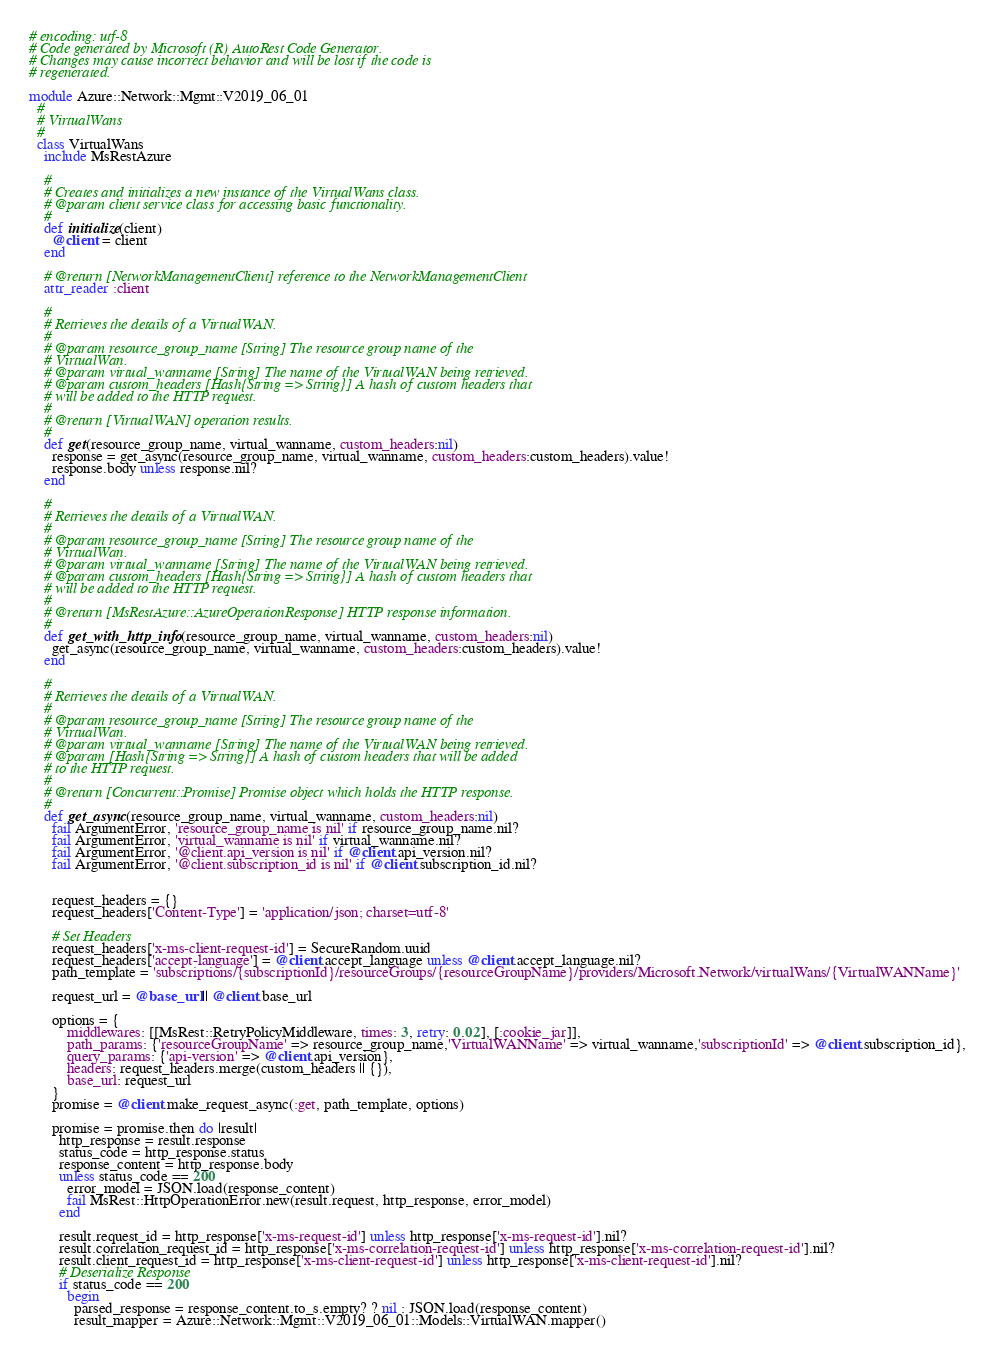Convert code to text. <code><loc_0><loc_0><loc_500><loc_500><_Ruby_># encoding: utf-8
# Code generated by Microsoft (R) AutoRest Code Generator.
# Changes may cause incorrect behavior and will be lost if the code is
# regenerated.

module Azure::Network::Mgmt::V2019_06_01
  #
  # VirtualWans
  #
  class VirtualWans
    include MsRestAzure

    #
    # Creates and initializes a new instance of the VirtualWans class.
    # @param client service class for accessing basic functionality.
    #
    def initialize(client)
      @client = client
    end

    # @return [NetworkManagementClient] reference to the NetworkManagementClient
    attr_reader :client

    #
    # Retrieves the details of a VirtualWAN.
    #
    # @param resource_group_name [String] The resource group name of the
    # VirtualWan.
    # @param virtual_wanname [String] The name of the VirtualWAN being retrieved.
    # @param custom_headers [Hash{String => String}] A hash of custom headers that
    # will be added to the HTTP request.
    #
    # @return [VirtualWAN] operation results.
    #
    def get(resource_group_name, virtual_wanname, custom_headers:nil)
      response = get_async(resource_group_name, virtual_wanname, custom_headers:custom_headers).value!
      response.body unless response.nil?
    end

    #
    # Retrieves the details of a VirtualWAN.
    #
    # @param resource_group_name [String] The resource group name of the
    # VirtualWan.
    # @param virtual_wanname [String] The name of the VirtualWAN being retrieved.
    # @param custom_headers [Hash{String => String}] A hash of custom headers that
    # will be added to the HTTP request.
    #
    # @return [MsRestAzure::AzureOperationResponse] HTTP response information.
    #
    def get_with_http_info(resource_group_name, virtual_wanname, custom_headers:nil)
      get_async(resource_group_name, virtual_wanname, custom_headers:custom_headers).value!
    end

    #
    # Retrieves the details of a VirtualWAN.
    #
    # @param resource_group_name [String] The resource group name of the
    # VirtualWan.
    # @param virtual_wanname [String] The name of the VirtualWAN being retrieved.
    # @param [Hash{String => String}] A hash of custom headers that will be added
    # to the HTTP request.
    #
    # @return [Concurrent::Promise] Promise object which holds the HTTP response.
    #
    def get_async(resource_group_name, virtual_wanname, custom_headers:nil)
      fail ArgumentError, 'resource_group_name is nil' if resource_group_name.nil?
      fail ArgumentError, 'virtual_wanname is nil' if virtual_wanname.nil?
      fail ArgumentError, '@client.api_version is nil' if @client.api_version.nil?
      fail ArgumentError, '@client.subscription_id is nil' if @client.subscription_id.nil?


      request_headers = {}
      request_headers['Content-Type'] = 'application/json; charset=utf-8'

      # Set Headers
      request_headers['x-ms-client-request-id'] = SecureRandom.uuid
      request_headers['accept-language'] = @client.accept_language unless @client.accept_language.nil?
      path_template = 'subscriptions/{subscriptionId}/resourceGroups/{resourceGroupName}/providers/Microsoft.Network/virtualWans/{VirtualWANName}'

      request_url = @base_url || @client.base_url

      options = {
          middlewares: [[MsRest::RetryPolicyMiddleware, times: 3, retry: 0.02], [:cookie_jar]],
          path_params: {'resourceGroupName' => resource_group_name,'VirtualWANName' => virtual_wanname,'subscriptionId' => @client.subscription_id},
          query_params: {'api-version' => @client.api_version},
          headers: request_headers.merge(custom_headers || {}),
          base_url: request_url
      }
      promise = @client.make_request_async(:get, path_template, options)

      promise = promise.then do |result|
        http_response = result.response
        status_code = http_response.status
        response_content = http_response.body
        unless status_code == 200
          error_model = JSON.load(response_content)
          fail MsRest::HttpOperationError.new(result.request, http_response, error_model)
        end

        result.request_id = http_response['x-ms-request-id'] unless http_response['x-ms-request-id'].nil?
        result.correlation_request_id = http_response['x-ms-correlation-request-id'] unless http_response['x-ms-correlation-request-id'].nil?
        result.client_request_id = http_response['x-ms-client-request-id'] unless http_response['x-ms-client-request-id'].nil?
        # Deserialize Response
        if status_code == 200
          begin
            parsed_response = response_content.to_s.empty? ? nil : JSON.load(response_content)
            result_mapper = Azure::Network::Mgmt::V2019_06_01::Models::VirtualWAN.mapper()</code> 